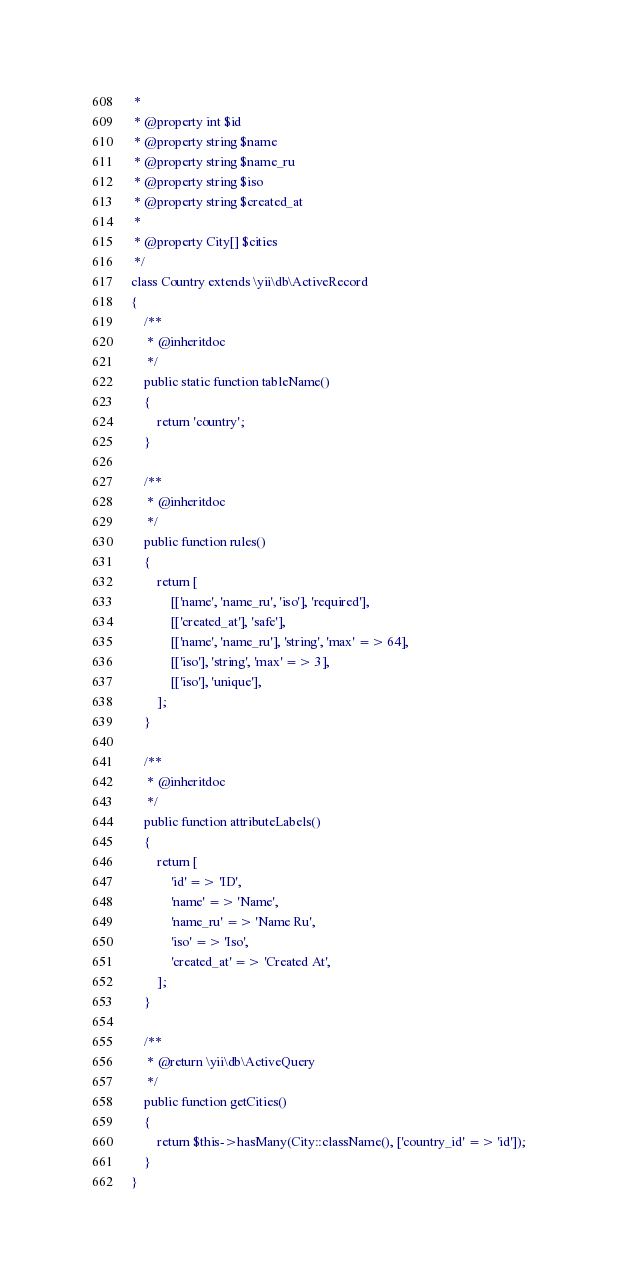<code> <loc_0><loc_0><loc_500><loc_500><_PHP_> *
 * @property int $id
 * @property string $name
 * @property string $name_ru
 * @property string $iso
 * @property string $created_at
 *
 * @property City[] $cities
 */
class Country extends \yii\db\ActiveRecord
{
    /**
     * @inheritdoc
     */
    public static function tableName()
    {
        return 'country';
    }

    /**
     * @inheritdoc
     */
    public function rules()
    {
        return [
            [['name', 'name_ru', 'iso'], 'required'],
            [['created_at'], 'safe'],
            [['name', 'name_ru'], 'string', 'max' => 64],
            [['iso'], 'string', 'max' => 3],
            [['iso'], 'unique'],
        ];
    }

    /**
     * @inheritdoc
     */
    public function attributeLabels()
    {
        return [
            'id' => 'ID',
            'name' => 'Name',
            'name_ru' => 'Name Ru',
            'iso' => 'Iso',
            'created_at' => 'Created At',
        ];
    }

    /**
     * @return \yii\db\ActiveQuery
     */
    public function getCities()
    {
        return $this->hasMany(City::className(), ['country_id' => 'id']);
    }
}
</code> 